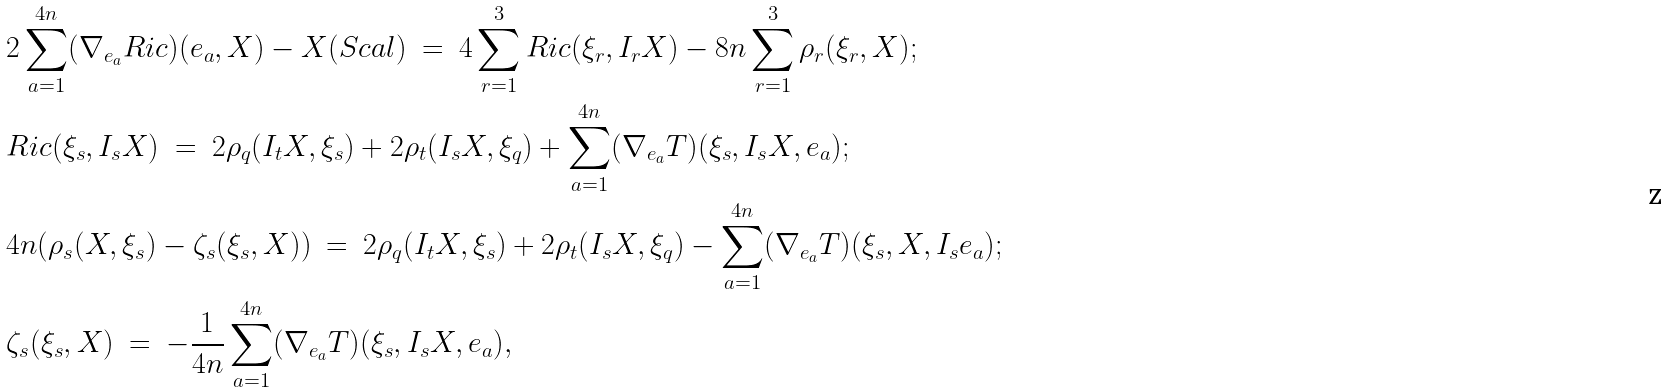<formula> <loc_0><loc_0><loc_500><loc_500>& 2 \sum _ { a = 1 } ^ { 4 n } ( \nabla _ { e _ { a } } R i c ) ( e _ { a } , X ) - X ( S c a l ) \ = \ 4 \sum _ { r = 1 } ^ { 3 } R i c ( \xi _ { r } , I _ { r } X ) - 8 n \sum _ { r = 1 } ^ { 3 } \rho _ { r } ( \xi _ { r } , X ) ; \\ & R i c ( \xi _ { s } , I _ { s } X ) \ = \ 2 \rho _ { q } ( I _ { t } X , \xi _ { s } ) + 2 \rho _ { t } ( I _ { s } X , \xi _ { q } ) + \sum _ { a = 1 } ^ { 4 n } ( \nabla _ { e _ { a } } T ) ( \xi _ { s } , I _ { s } X , e _ { a } ) ; \\ & 4 n ( \rho _ { s } ( X , \xi _ { s } ) - \zeta _ { s } ( \xi _ { s } , X ) ) \ = \ 2 \rho _ { q } ( I _ { t } X , \xi _ { s } ) + 2 \rho _ { t } ( I _ { s } X , \xi _ { q } ) - \sum _ { a = 1 } ^ { 4 n } ( \nabla _ { e _ { a } } T ) ( \xi _ { s } , X , I _ { s } e _ { a } ) ; \\ & \zeta _ { s } ( \xi _ { s } , X ) \ = \ - \frac { 1 } { 4 n } \sum _ { a = 1 } ^ { 4 n } ( \nabla _ { e _ { a } } T ) ( \xi _ { s } , I _ { s } X , e _ { a } ) ,</formula> 